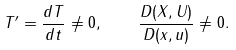Convert formula to latex. <formula><loc_0><loc_0><loc_500><loc_500>T ^ { \prime } = \frac { d T } { d t } \not = 0 , \quad \frac { D ( X , U ) } { D ( x , u ) } \not = 0 .</formula> 